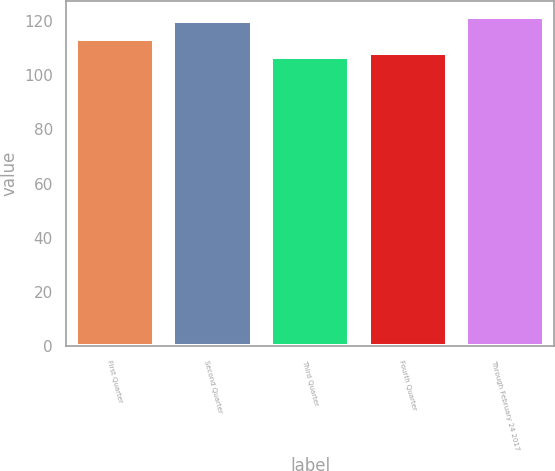Convert chart to OTSL. <chart><loc_0><loc_0><loc_500><loc_500><bar_chart><fcel>First Quarter<fcel>Second Quarter<fcel>Third Quarter<fcel>Fourth Quarter<fcel>Through February 24 2017<nl><fcel>113.4<fcel>119.95<fcel>106.57<fcel>108<fcel>121.38<nl></chart> 